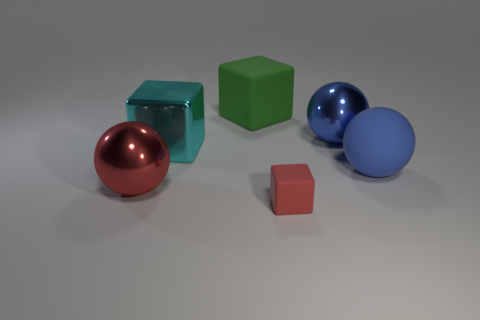Add 3 gray shiny objects. How many objects exist? 9 Add 1 big blue metal spheres. How many big blue metal spheres are left? 2 Add 4 cyan metallic objects. How many cyan metallic objects exist? 5 Subtract 0 purple cubes. How many objects are left? 6 Subtract all purple matte cubes. Subtract all red blocks. How many objects are left? 5 